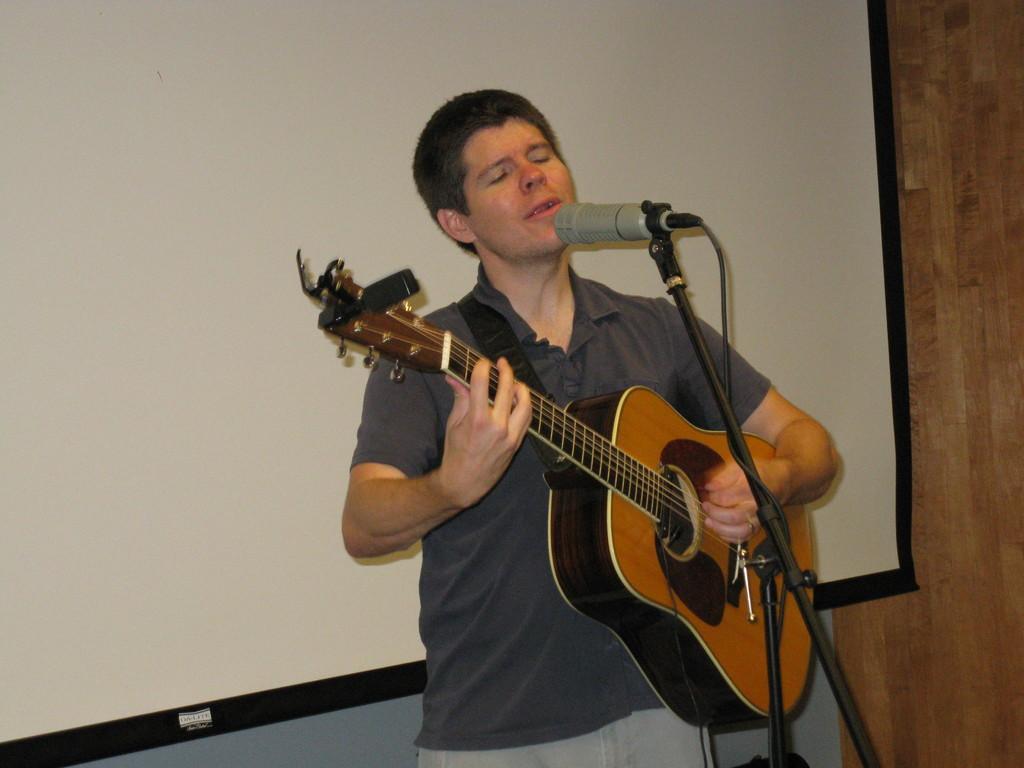Can you describe this image briefly? In this picture we can see a man who is playing guitar. He is singing on the mike. On the background there is a screen. And this is wall. 